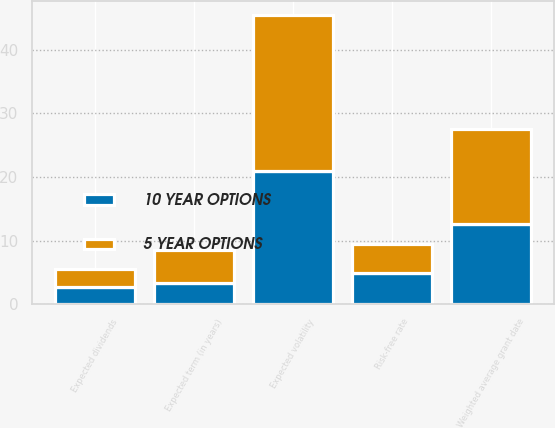Convert chart to OTSL. <chart><loc_0><loc_0><loc_500><loc_500><stacked_bar_chart><ecel><fcel>Expected volatility<fcel>Expected dividends<fcel>Expected term (in years)<fcel>Risk-free rate<fcel>Weighted average grant date<nl><fcel>10 YEAR OPTIONS<fcel>20.92<fcel>2.7<fcel>3.38<fcel>4.88<fcel>12.52<nl><fcel>5 YEAR OPTIONS<fcel>24.5<fcel>2.86<fcel>5.21<fcel>4.6<fcel>14.98<nl></chart> 